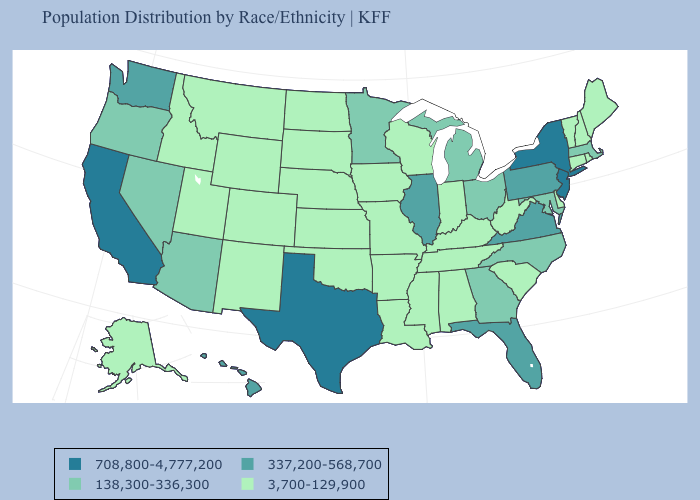Does the first symbol in the legend represent the smallest category?
Quick response, please. No. Name the states that have a value in the range 3,700-129,900?
Quick response, please. Alabama, Alaska, Arkansas, Colorado, Connecticut, Delaware, Idaho, Indiana, Iowa, Kansas, Kentucky, Louisiana, Maine, Mississippi, Missouri, Montana, Nebraska, New Hampshire, New Mexico, North Dakota, Oklahoma, Rhode Island, South Carolina, South Dakota, Tennessee, Utah, Vermont, West Virginia, Wisconsin, Wyoming. Which states hav the highest value in the West?
Give a very brief answer. California. Does Missouri have a lower value than Alaska?
Write a very short answer. No. What is the value of Tennessee?
Give a very brief answer. 3,700-129,900. Name the states that have a value in the range 3,700-129,900?
Quick response, please. Alabama, Alaska, Arkansas, Colorado, Connecticut, Delaware, Idaho, Indiana, Iowa, Kansas, Kentucky, Louisiana, Maine, Mississippi, Missouri, Montana, Nebraska, New Hampshire, New Mexico, North Dakota, Oklahoma, Rhode Island, South Carolina, South Dakota, Tennessee, Utah, Vermont, West Virginia, Wisconsin, Wyoming. How many symbols are there in the legend?
Keep it brief. 4. Does Missouri have the highest value in the USA?
Keep it brief. No. What is the value of Connecticut?
Give a very brief answer. 3,700-129,900. How many symbols are there in the legend?
Concise answer only. 4. What is the value of Utah?
Concise answer only. 3,700-129,900. Name the states that have a value in the range 708,800-4,777,200?
Give a very brief answer. California, New Jersey, New York, Texas. What is the value of Kansas?
Quick response, please. 3,700-129,900. Name the states that have a value in the range 337,200-568,700?
Answer briefly. Florida, Hawaii, Illinois, Pennsylvania, Virginia, Washington. What is the highest value in the USA?
Write a very short answer. 708,800-4,777,200. 